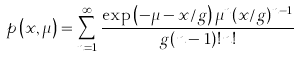<formula> <loc_0><loc_0><loc_500><loc_500>p \left ( x , \mu \right ) = \sum _ { n = 1 } ^ { \infty } \frac { \exp \left ( - \mu - x / g \right ) \mu ^ { n } ( x / g ) ^ { n - 1 } } { g ( n - 1 ) ! n ! }</formula> 